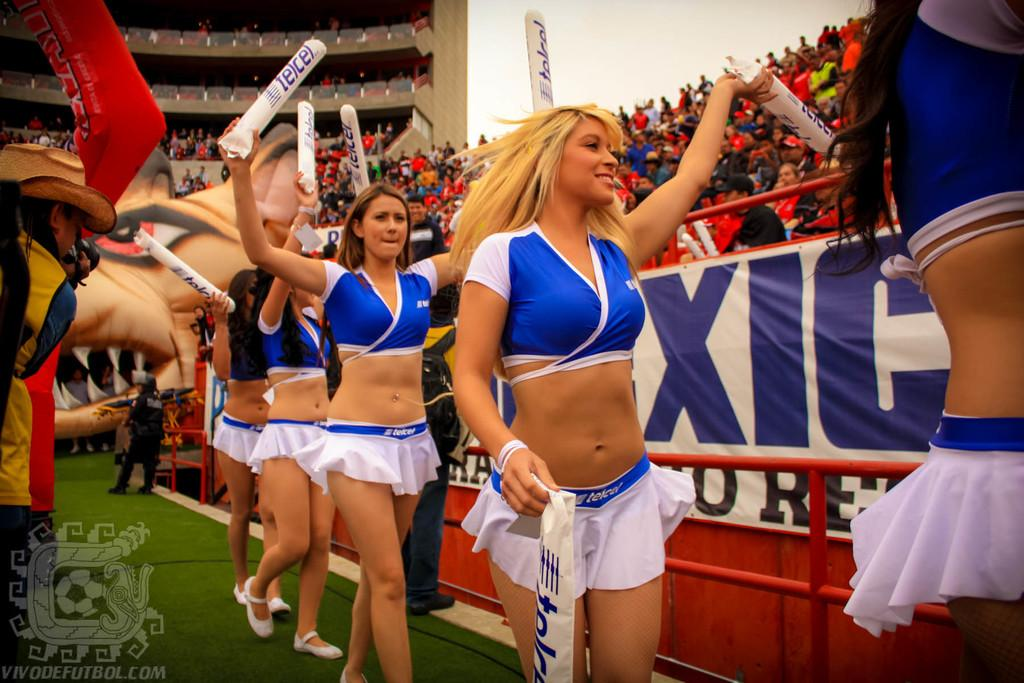<image>
Present a compact description of the photo's key features. Cheerleaders in front of a banner with XIC on it. 